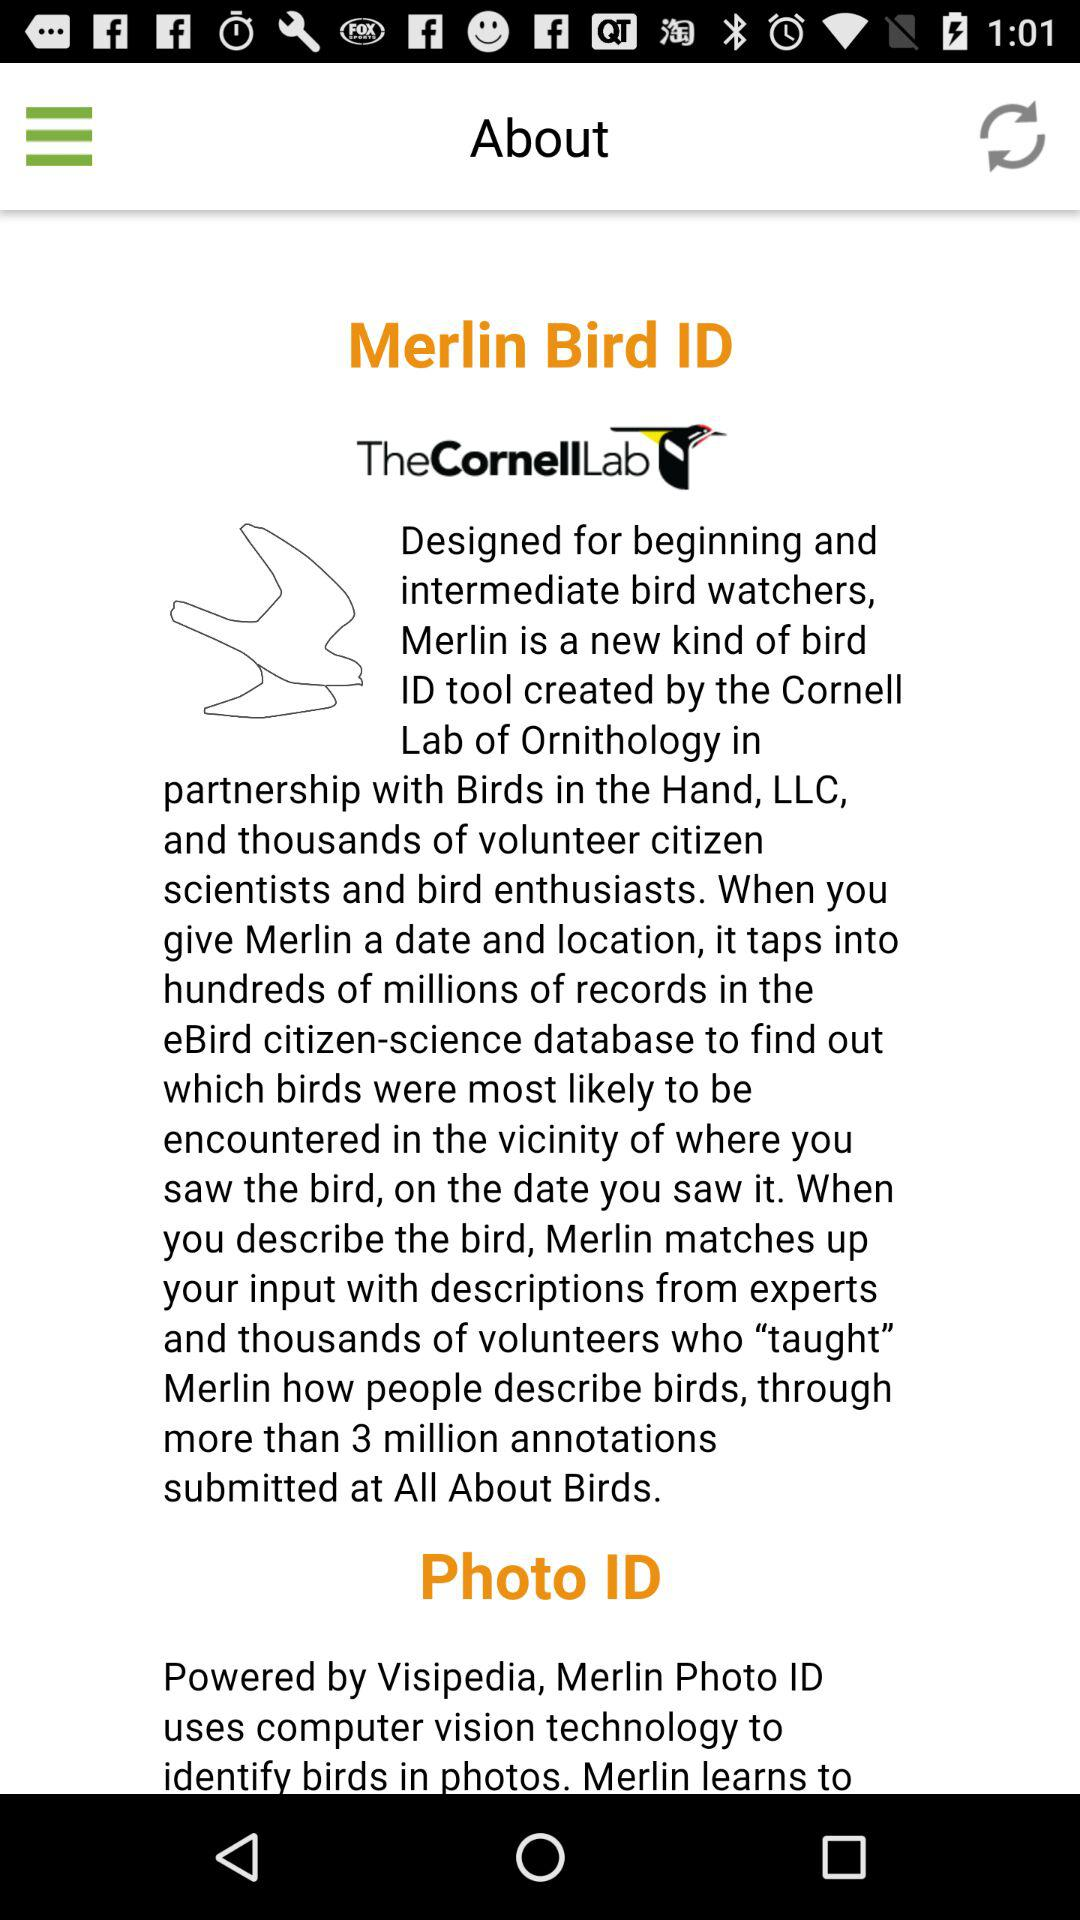What is photo Id?
When the provided information is insufficient, respond with <no answer>. <no answer> 